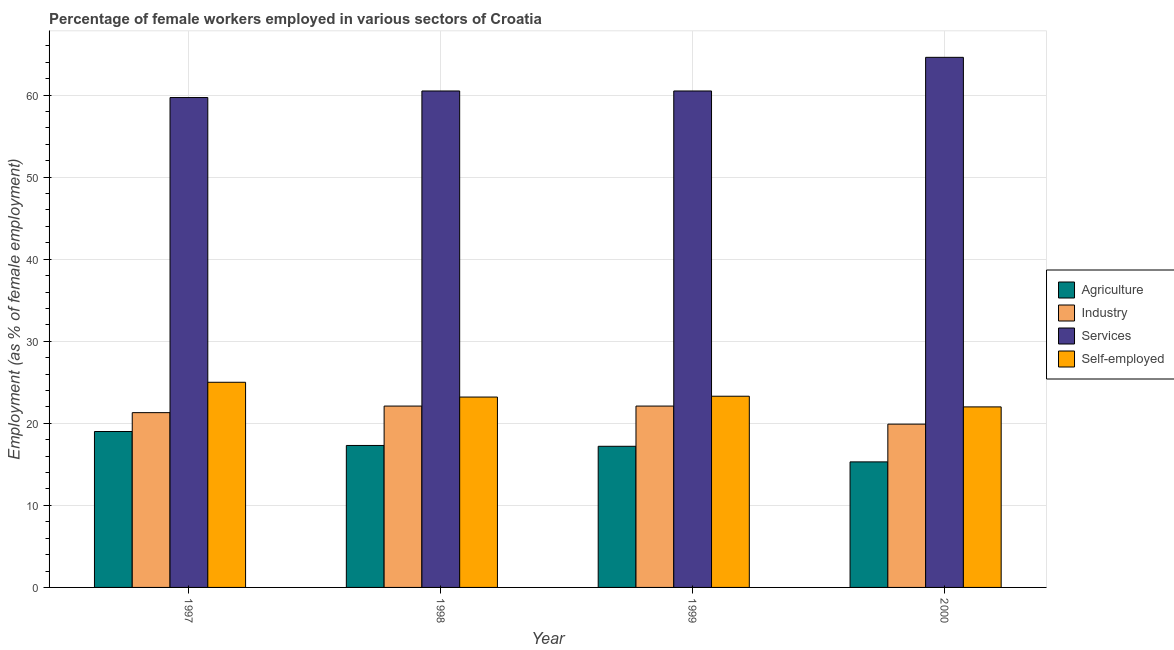How many different coloured bars are there?
Provide a short and direct response. 4. Are the number of bars per tick equal to the number of legend labels?
Provide a succinct answer. Yes. Are the number of bars on each tick of the X-axis equal?
Give a very brief answer. Yes. In how many cases, is the number of bars for a given year not equal to the number of legend labels?
Make the answer very short. 0. What is the percentage of self employed female workers in 1998?
Give a very brief answer. 23.2. Across all years, what is the maximum percentage of self employed female workers?
Your answer should be compact. 25. Across all years, what is the minimum percentage of female workers in industry?
Ensure brevity in your answer.  19.9. In which year was the percentage of self employed female workers minimum?
Your answer should be compact. 2000. What is the total percentage of female workers in agriculture in the graph?
Keep it short and to the point. 68.8. What is the difference between the percentage of self employed female workers in 1997 and that in 1999?
Provide a short and direct response. 1.7. What is the difference between the percentage of female workers in agriculture in 1997 and the percentage of female workers in industry in 2000?
Provide a short and direct response. 3.7. What is the average percentage of female workers in industry per year?
Offer a terse response. 21.35. In the year 1997, what is the difference between the percentage of female workers in agriculture and percentage of female workers in services?
Make the answer very short. 0. What is the ratio of the percentage of self employed female workers in 1997 to that in 1998?
Keep it short and to the point. 1.08. Is the percentage of female workers in services in 1997 less than that in 1999?
Keep it short and to the point. Yes. What is the difference between the highest and the second highest percentage of female workers in agriculture?
Provide a succinct answer. 1.7. What is the difference between the highest and the lowest percentage of female workers in services?
Your answer should be compact. 4.9. In how many years, is the percentage of self employed female workers greater than the average percentage of self employed female workers taken over all years?
Your answer should be very brief. 1. Is it the case that in every year, the sum of the percentage of self employed female workers and percentage of female workers in services is greater than the sum of percentage of female workers in industry and percentage of female workers in agriculture?
Your answer should be very brief. No. What does the 4th bar from the left in 1998 represents?
Your answer should be very brief. Self-employed. What does the 4th bar from the right in 1998 represents?
Give a very brief answer. Agriculture. Is it the case that in every year, the sum of the percentage of female workers in agriculture and percentage of female workers in industry is greater than the percentage of female workers in services?
Keep it short and to the point. No. How many bars are there?
Provide a short and direct response. 16. Are all the bars in the graph horizontal?
Ensure brevity in your answer.  No. What is the difference between two consecutive major ticks on the Y-axis?
Offer a terse response. 10. Are the values on the major ticks of Y-axis written in scientific E-notation?
Your response must be concise. No. Does the graph contain grids?
Give a very brief answer. Yes. Where does the legend appear in the graph?
Give a very brief answer. Center right. How are the legend labels stacked?
Provide a short and direct response. Vertical. What is the title of the graph?
Your answer should be very brief. Percentage of female workers employed in various sectors of Croatia. Does "Interest Payments" appear as one of the legend labels in the graph?
Make the answer very short. No. What is the label or title of the X-axis?
Make the answer very short. Year. What is the label or title of the Y-axis?
Make the answer very short. Employment (as % of female employment). What is the Employment (as % of female employment) of Agriculture in 1997?
Offer a very short reply. 19. What is the Employment (as % of female employment) in Industry in 1997?
Make the answer very short. 21.3. What is the Employment (as % of female employment) of Services in 1997?
Ensure brevity in your answer.  59.7. What is the Employment (as % of female employment) in Self-employed in 1997?
Offer a very short reply. 25. What is the Employment (as % of female employment) in Agriculture in 1998?
Your answer should be compact. 17.3. What is the Employment (as % of female employment) of Industry in 1998?
Offer a terse response. 22.1. What is the Employment (as % of female employment) in Services in 1998?
Keep it short and to the point. 60.5. What is the Employment (as % of female employment) in Self-employed in 1998?
Give a very brief answer. 23.2. What is the Employment (as % of female employment) in Agriculture in 1999?
Ensure brevity in your answer.  17.2. What is the Employment (as % of female employment) in Industry in 1999?
Ensure brevity in your answer.  22.1. What is the Employment (as % of female employment) of Services in 1999?
Your response must be concise. 60.5. What is the Employment (as % of female employment) in Self-employed in 1999?
Your answer should be compact. 23.3. What is the Employment (as % of female employment) in Agriculture in 2000?
Offer a terse response. 15.3. What is the Employment (as % of female employment) of Industry in 2000?
Provide a short and direct response. 19.9. What is the Employment (as % of female employment) of Services in 2000?
Keep it short and to the point. 64.6. Across all years, what is the maximum Employment (as % of female employment) of Industry?
Provide a short and direct response. 22.1. Across all years, what is the maximum Employment (as % of female employment) of Services?
Your answer should be compact. 64.6. Across all years, what is the maximum Employment (as % of female employment) in Self-employed?
Make the answer very short. 25. Across all years, what is the minimum Employment (as % of female employment) in Agriculture?
Give a very brief answer. 15.3. Across all years, what is the minimum Employment (as % of female employment) in Industry?
Provide a short and direct response. 19.9. Across all years, what is the minimum Employment (as % of female employment) in Services?
Your answer should be compact. 59.7. Across all years, what is the minimum Employment (as % of female employment) in Self-employed?
Your response must be concise. 22. What is the total Employment (as % of female employment) in Agriculture in the graph?
Your response must be concise. 68.8. What is the total Employment (as % of female employment) in Industry in the graph?
Ensure brevity in your answer.  85.4. What is the total Employment (as % of female employment) of Services in the graph?
Your answer should be compact. 245.3. What is the total Employment (as % of female employment) in Self-employed in the graph?
Offer a terse response. 93.5. What is the difference between the Employment (as % of female employment) of Agriculture in 1997 and that in 1998?
Your response must be concise. 1.7. What is the difference between the Employment (as % of female employment) of Industry in 1997 and that in 1998?
Provide a succinct answer. -0.8. What is the difference between the Employment (as % of female employment) in Industry in 1997 and that in 1999?
Your response must be concise. -0.8. What is the difference between the Employment (as % of female employment) of Services in 1997 and that in 1999?
Your response must be concise. -0.8. What is the difference between the Employment (as % of female employment) in Agriculture in 1997 and that in 2000?
Provide a succinct answer. 3.7. What is the difference between the Employment (as % of female employment) in Industry in 1997 and that in 2000?
Your answer should be very brief. 1.4. What is the difference between the Employment (as % of female employment) of Services in 1997 and that in 2000?
Provide a succinct answer. -4.9. What is the difference between the Employment (as % of female employment) of Self-employed in 1997 and that in 2000?
Keep it short and to the point. 3. What is the difference between the Employment (as % of female employment) in Industry in 1998 and that in 1999?
Keep it short and to the point. 0. What is the difference between the Employment (as % of female employment) in Agriculture in 1998 and that in 2000?
Ensure brevity in your answer.  2. What is the difference between the Employment (as % of female employment) in Industry in 1998 and that in 2000?
Ensure brevity in your answer.  2.2. What is the difference between the Employment (as % of female employment) of Services in 1998 and that in 2000?
Provide a succinct answer. -4.1. What is the difference between the Employment (as % of female employment) in Agriculture in 1999 and that in 2000?
Your answer should be compact. 1.9. What is the difference between the Employment (as % of female employment) in Industry in 1999 and that in 2000?
Ensure brevity in your answer.  2.2. What is the difference between the Employment (as % of female employment) of Self-employed in 1999 and that in 2000?
Keep it short and to the point. 1.3. What is the difference between the Employment (as % of female employment) in Agriculture in 1997 and the Employment (as % of female employment) in Industry in 1998?
Your answer should be very brief. -3.1. What is the difference between the Employment (as % of female employment) in Agriculture in 1997 and the Employment (as % of female employment) in Services in 1998?
Keep it short and to the point. -41.5. What is the difference between the Employment (as % of female employment) of Agriculture in 1997 and the Employment (as % of female employment) of Self-employed in 1998?
Your response must be concise. -4.2. What is the difference between the Employment (as % of female employment) in Industry in 1997 and the Employment (as % of female employment) in Services in 1998?
Provide a succinct answer. -39.2. What is the difference between the Employment (as % of female employment) in Industry in 1997 and the Employment (as % of female employment) in Self-employed in 1998?
Your answer should be very brief. -1.9. What is the difference between the Employment (as % of female employment) of Services in 1997 and the Employment (as % of female employment) of Self-employed in 1998?
Ensure brevity in your answer.  36.5. What is the difference between the Employment (as % of female employment) of Agriculture in 1997 and the Employment (as % of female employment) of Industry in 1999?
Offer a very short reply. -3.1. What is the difference between the Employment (as % of female employment) of Agriculture in 1997 and the Employment (as % of female employment) of Services in 1999?
Provide a short and direct response. -41.5. What is the difference between the Employment (as % of female employment) of Agriculture in 1997 and the Employment (as % of female employment) of Self-employed in 1999?
Make the answer very short. -4.3. What is the difference between the Employment (as % of female employment) in Industry in 1997 and the Employment (as % of female employment) in Services in 1999?
Keep it short and to the point. -39.2. What is the difference between the Employment (as % of female employment) in Industry in 1997 and the Employment (as % of female employment) in Self-employed in 1999?
Provide a short and direct response. -2. What is the difference between the Employment (as % of female employment) of Services in 1997 and the Employment (as % of female employment) of Self-employed in 1999?
Provide a succinct answer. 36.4. What is the difference between the Employment (as % of female employment) of Agriculture in 1997 and the Employment (as % of female employment) of Industry in 2000?
Give a very brief answer. -0.9. What is the difference between the Employment (as % of female employment) of Agriculture in 1997 and the Employment (as % of female employment) of Services in 2000?
Make the answer very short. -45.6. What is the difference between the Employment (as % of female employment) in Industry in 1997 and the Employment (as % of female employment) in Services in 2000?
Offer a terse response. -43.3. What is the difference between the Employment (as % of female employment) of Industry in 1997 and the Employment (as % of female employment) of Self-employed in 2000?
Your answer should be compact. -0.7. What is the difference between the Employment (as % of female employment) of Services in 1997 and the Employment (as % of female employment) of Self-employed in 2000?
Ensure brevity in your answer.  37.7. What is the difference between the Employment (as % of female employment) of Agriculture in 1998 and the Employment (as % of female employment) of Services in 1999?
Ensure brevity in your answer.  -43.2. What is the difference between the Employment (as % of female employment) of Industry in 1998 and the Employment (as % of female employment) of Services in 1999?
Give a very brief answer. -38.4. What is the difference between the Employment (as % of female employment) of Industry in 1998 and the Employment (as % of female employment) of Self-employed in 1999?
Provide a succinct answer. -1.2. What is the difference between the Employment (as % of female employment) of Services in 1998 and the Employment (as % of female employment) of Self-employed in 1999?
Give a very brief answer. 37.2. What is the difference between the Employment (as % of female employment) of Agriculture in 1998 and the Employment (as % of female employment) of Industry in 2000?
Keep it short and to the point. -2.6. What is the difference between the Employment (as % of female employment) in Agriculture in 1998 and the Employment (as % of female employment) in Services in 2000?
Provide a succinct answer. -47.3. What is the difference between the Employment (as % of female employment) of Industry in 1998 and the Employment (as % of female employment) of Services in 2000?
Keep it short and to the point. -42.5. What is the difference between the Employment (as % of female employment) of Industry in 1998 and the Employment (as % of female employment) of Self-employed in 2000?
Give a very brief answer. 0.1. What is the difference between the Employment (as % of female employment) in Services in 1998 and the Employment (as % of female employment) in Self-employed in 2000?
Your response must be concise. 38.5. What is the difference between the Employment (as % of female employment) in Agriculture in 1999 and the Employment (as % of female employment) in Industry in 2000?
Keep it short and to the point. -2.7. What is the difference between the Employment (as % of female employment) of Agriculture in 1999 and the Employment (as % of female employment) of Services in 2000?
Give a very brief answer. -47.4. What is the difference between the Employment (as % of female employment) of Industry in 1999 and the Employment (as % of female employment) of Services in 2000?
Provide a short and direct response. -42.5. What is the difference between the Employment (as % of female employment) of Services in 1999 and the Employment (as % of female employment) of Self-employed in 2000?
Your response must be concise. 38.5. What is the average Employment (as % of female employment) in Industry per year?
Offer a very short reply. 21.35. What is the average Employment (as % of female employment) of Services per year?
Your answer should be compact. 61.33. What is the average Employment (as % of female employment) of Self-employed per year?
Provide a short and direct response. 23.38. In the year 1997, what is the difference between the Employment (as % of female employment) in Agriculture and Employment (as % of female employment) in Industry?
Your answer should be compact. -2.3. In the year 1997, what is the difference between the Employment (as % of female employment) of Agriculture and Employment (as % of female employment) of Services?
Your answer should be compact. -40.7. In the year 1997, what is the difference between the Employment (as % of female employment) of Agriculture and Employment (as % of female employment) of Self-employed?
Keep it short and to the point. -6. In the year 1997, what is the difference between the Employment (as % of female employment) of Industry and Employment (as % of female employment) of Services?
Offer a very short reply. -38.4. In the year 1997, what is the difference between the Employment (as % of female employment) in Services and Employment (as % of female employment) in Self-employed?
Give a very brief answer. 34.7. In the year 1998, what is the difference between the Employment (as % of female employment) in Agriculture and Employment (as % of female employment) in Industry?
Make the answer very short. -4.8. In the year 1998, what is the difference between the Employment (as % of female employment) in Agriculture and Employment (as % of female employment) in Services?
Your response must be concise. -43.2. In the year 1998, what is the difference between the Employment (as % of female employment) in Agriculture and Employment (as % of female employment) in Self-employed?
Offer a very short reply. -5.9. In the year 1998, what is the difference between the Employment (as % of female employment) of Industry and Employment (as % of female employment) of Services?
Your answer should be very brief. -38.4. In the year 1998, what is the difference between the Employment (as % of female employment) in Industry and Employment (as % of female employment) in Self-employed?
Make the answer very short. -1.1. In the year 1998, what is the difference between the Employment (as % of female employment) in Services and Employment (as % of female employment) in Self-employed?
Provide a short and direct response. 37.3. In the year 1999, what is the difference between the Employment (as % of female employment) of Agriculture and Employment (as % of female employment) of Industry?
Keep it short and to the point. -4.9. In the year 1999, what is the difference between the Employment (as % of female employment) in Agriculture and Employment (as % of female employment) in Services?
Provide a short and direct response. -43.3. In the year 1999, what is the difference between the Employment (as % of female employment) of Industry and Employment (as % of female employment) of Services?
Your answer should be very brief. -38.4. In the year 1999, what is the difference between the Employment (as % of female employment) of Services and Employment (as % of female employment) of Self-employed?
Make the answer very short. 37.2. In the year 2000, what is the difference between the Employment (as % of female employment) of Agriculture and Employment (as % of female employment) of Industry?
Give a very brief answer. -4.6. In the year 2000, what is the difference between the Employment (as % of female employment) in Agriculture and Employment (as % of female employment) in Services?
Make the answer very short. -49.3. In the year 2000, what is the difference between the Employment (as % of female employment) in Industry and Employment (as % of female employment) in Services?
Provide a succinct answer. -44.7. In the year 2000, what is the difference between the Employment (as % of female employment) in Services and Employment (as % of female employment) in Self-employed?
Your answer should be compact. 42.6. What is the ratio of the Employment (as % of female employment) of Agriculture in 1997 to that in 1998?
Ensure brevity in your answer.  1.1. What is the ratio of the Employment (as % of female employment) of Industry in 1997 to that in 1998?
Offer a very short reply. 0.96. What is the ratio of the Employment (as % of female employment) in Self-employed in 1997 to that in 1998?
Ensure brevity in your answer.  1.08. What is the ratio of the Employment (as % of female employment) of Agriculture in 1997 to that in 1999?
Your answer should be compact. 1.1. What is the ratio of the Employment (as % of female employment) in Industry in 1997 to that in 1999?
Provide a succinct answer. 0.96. What is the ratio of the Employment (as % of female employment) of Self-employed in 1997 to that in 1999?
Your answer should be very brief. 1.07. What is the ratio of the Employment (as % of female employment) of Agriculture in 1997 to that in 2000?
Make the answer very short. 1.24. What is the ratio of the Employment (as % of female employment) of Industry in 1997 to that in 2000?
Provide a succinct answer. 1.07. What is the ratio of the Employment (as % of female employment) of Services in 1997 to that in 2000?
Make the answer very short. 0.92. What is the ratio of the Employment (as % of female employment) in Self-employed in 1997 to that in 2000?
Provide a succinct answer. 1.14. What is the ratio of the Employment (as % of female employment) in Industry in 1998 to that in 1999?
Keep it short and to the point. 1. What is the ratio of the Employment (as % of female employment) in Services in 1998 to that in 1999?
Offer a terse response. 1. What is the ratio of the Employment (as % of female employment) of Self-employed in 1998 to that in 1999?
Your response must be concise. 1. What is the ratio of the Employment (as % of female employment) of Agriculture in 1998 to that in 2000?
Give a very brief answer. 1.13. What is the ratio of the Employment (as % of female employment) of Industry in 1998 to that in 2000?
Make the answer very short. 1.11. What is the ratio of the Employment (as % of female employment) of Services in 1998 to that in 2000?
Your response must be concise. 0.94. What is the ratio of the Employment (as % of female employment) of Self-employed in 1998 to that in 2000?
Your answer should be very brief. 1.05. What is the ratio of the Employment (as % of female employment) in Agriculture in 1999 to that in 2000?
Your answer should be compact. 1.12. What is the ratio of the Employment (as % of female employment) of Industry in 1999 to that in 2000?
Your response must be concise. 1.11. What is the ratio of the Employment (as % of female employment) of Services in 1999 to that in 2000?
Ensure brevity in your answer.  0.94. What is the ratio of the Employment (as % of female employment) in Self-employed in 1999 to that in 2000?
Provide a short and direct response. 1.06. What is the difference between the highest and the lowest Employment (as % of female employment) of Agriculture?
Give a very brief answer. 3.7. What is the difference between the highest and the lowest Employment (as % of female employment) in Self-employed?
Give a very brief answer. 3. 